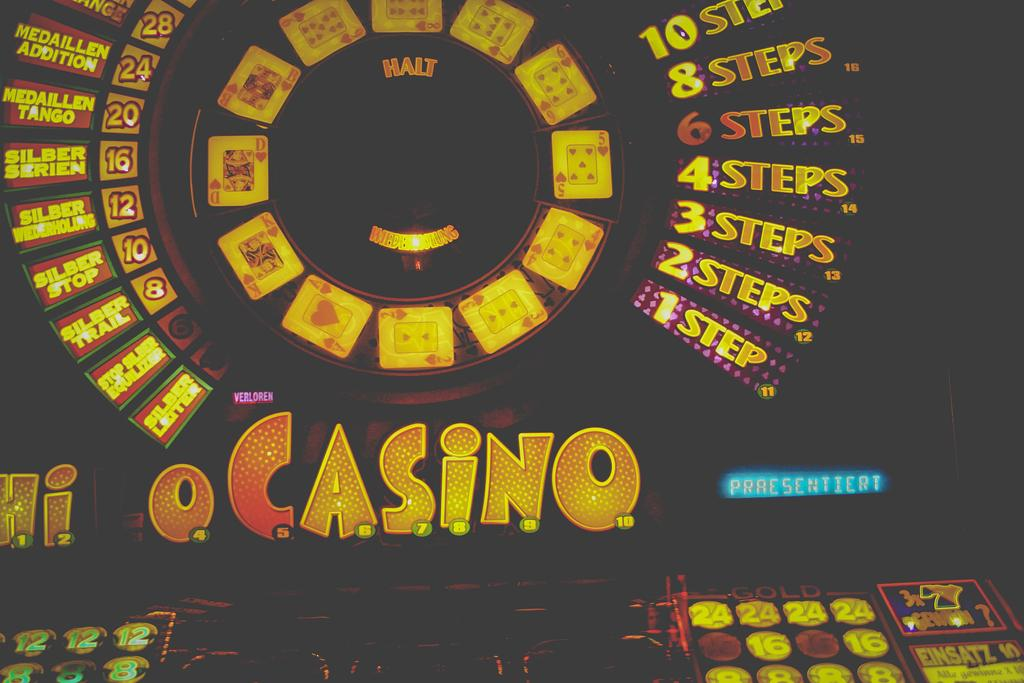<image>
Describe the image concisely. Slot machine screen that says "Casino " on it. 